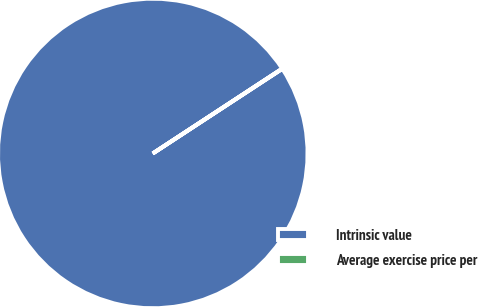Convert chart to OTSL. <chart><loc_0><loc_0><loc_500><loc_500><pie_chart><fcel>Intrinsic value<fcel>Average exercise price per<nl><fcel>99.97%<fcel>0.03%<nl></chart> 